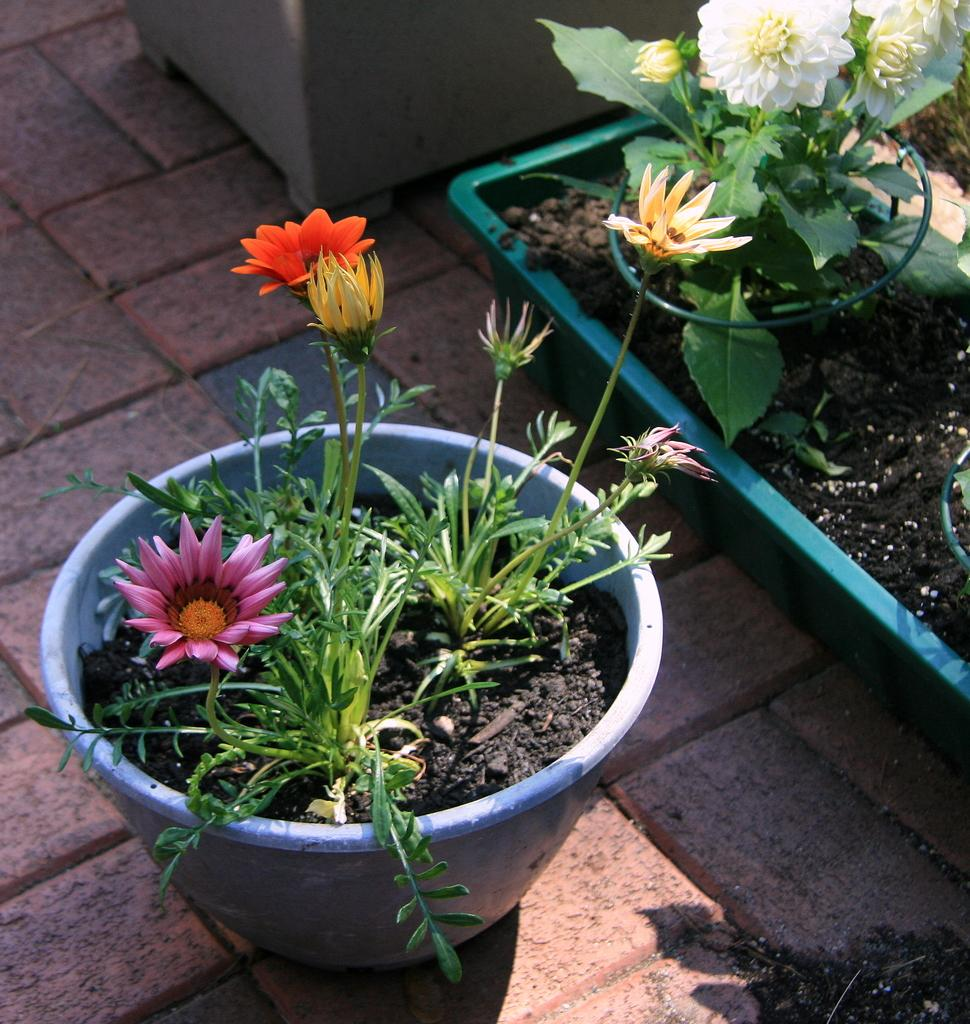Where was the picture taken? The picture was clicked outside. What is the main subject of the image? The main subject of the image is house plants. What can be observed about the flowers on the house plants? The house plants contain different colors of flowers. What can be seen in the background of the image? There is a pavement and a pot in the background of the image. What type of meal is being prepared on the pavement in the image? There is no meal being prepared in the image; the focus is on the house plants and the background elements. 